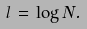<formula> <loc_0><loc_0><loc_500><loc_500>l \, = \, \log N .</formula> 